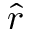<formula> <loc_0><loc_0><loc_500><loc_500>\hat { r }</formula> 